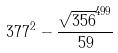<formula> <loc_0><loc_0><loc_500><loc_500>3 7 7 ^ { 2 } - \frac { \sqrt { 3 5 6 } ^ { 4 9 9 } } { 5 9 }</formula> 